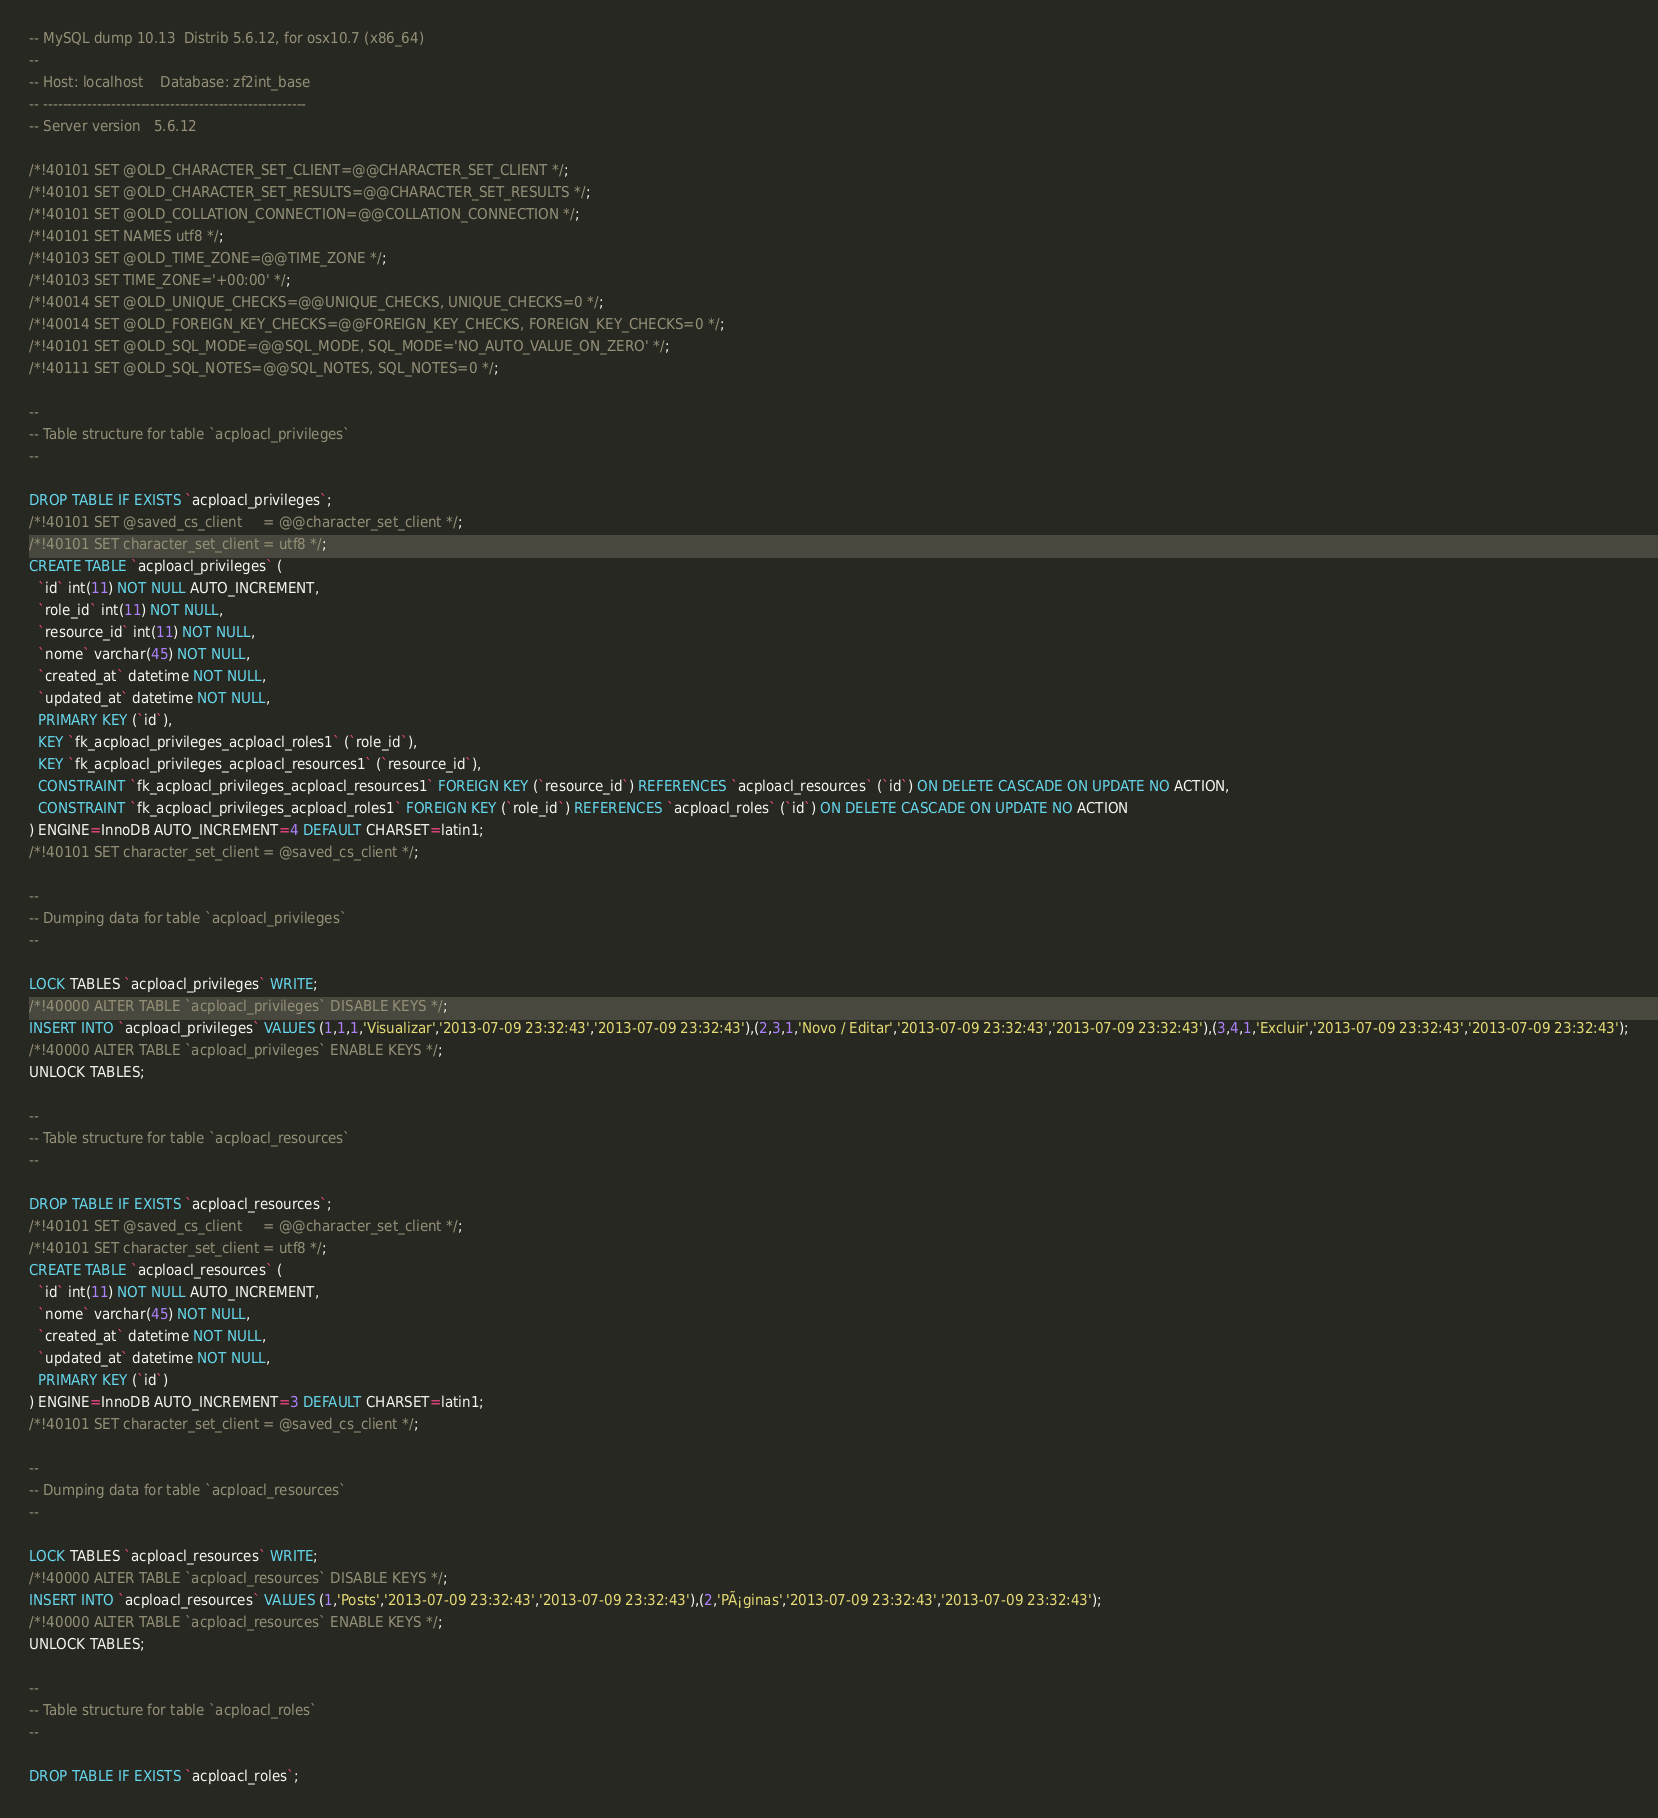Convert code to text. <code><loc_0><loc_0><loc_500><loc_500><_SQL_>-- MySQL dump 10.13  Distrib 5.6.12, for osx10.7 (x86_64)
--
-- Host: localhost    Database: zf2int_base
-- ------------------------------------------------------
-- Server version	5.6.12

/*!40101 SET @OLD_CHARACTER_SET_CLIENT=@@CHARACTER_SET_CLIENT */;
/*!40101 SET @OLD_CHARACTER_SET_RESULTS=@@CHARACTER_SET_RESULTS */;
/*!40101 SET @OLD_COLLATION_CONNECTION=@@COLLATION_CONNECTION */;
/*!40101 SET NAMES utf8 */;
/*!40103 SET @OLD_TIME_ZONE=@@TIME_ZONE */;
/*!40103 SET TIME_ZONE='+00:00' */;
/*!40014 SET @OLD_UNIQUE_CHECKS=@@UNIQUE_CHECKS, UNIQUE_CHECKS=0 */;
/*!40014 SET @OLD_FOREIGN_KEY_CHECKS=@@FOREIGN_KEY_CHECKS, FOREIGN_KEY_CHECKS=0 */;
/*!40101 SET @OLD_SQL_MODE=@@SQL_MODE, SQL_MODE='NO_AUTO_VALUE_ON_ZERO' */;
/*!40111 SET @OLD_SQL_NOTES=@@SQL_NOTES, SQL_NOTES=0 */;

--
-- Table structure for table `acploacl_privileges`
--

DROP TABLE IF EXISTS `acploacl_privileges`;
/*!40101 SET @saved_cs_client     = @@character_set_client */;
/*!40101 SET character_set_client = utf8 */;
CREATE TABLE `acploacl_privileges` (
  `id` int(11) NOT NULL AUTO_INCREMENT,
  `role_id` int(11) NOT NULL,
  `resource_id` int(11) NOT NULL,
  `nome` varchar(45) NOT NULL,
  `created_at` datetime NOT NULL,
  `updated_at` datetime NOT NULL,
  PRIMARY KEY (`id`),
  KEY `fk_acploacl_privileges_acploacl_roles1` (`role_id`),
  KEY `fk_acploacl_privileges_acploacl_resources1` (`resource_id`),
  CONSTRAINT `fk_acploacl_privileges_acploacl_resources1` FOREIGN KEY (`resource_id`) REFERENCES `acploacl_resources` (`id`) ON DELETE CASCADE ON UPDATE NO ACTION,
  CONSTRAINT `fk_acploacl_privileges_acploacl_roles1` FOREIGN KEY (`role_id`) REFERENCES `acploacl_roles` (`id`) ON DELETE CASCADE ON UPDATE NO ACTION
) ENGINE=InnoDB AUTO_INCREMENT=4 DEFAULT CHARSET=latin1;
/*!40101 SET character_set_client = @saved_cs_client */;

--
-- Dumping data for table `acploacl_privileges`
--

LOCK TABLES `acploacl_privileges` WRITE;
/*!40000 ALTER TABLE `acploacl_privileges` DISABLE KEYS */;
INSERT INTO `acploacl_privileges` VALUES (1,1,1,'Visualizar','2013-07-09 23:32:43','2013-07-09 23:32:43'),(2,3,1,'Novo / Editar','2013-07-09 23:32:43','2013-07-09 23:32:43'),(3,4,1,'Excluir','2013-07-09 23:32:43','2013-07-09 23:32:43');
/*!40000 ALTER TABLE `acploacl_privileges` ENABLE KEYS */;
UNLOCK TABLES;

--
-- Table structure for table `acploacl_resources`
--

DROP TABLE IF EXISTS `acploacl_resources`;
/*!40101 SET @saved_cs_client     = @@character_set_client */;
/*!40101 SET character_set_client = utf8 */;
CREATE TABLE `acploacl_resources` (
  `id` int(11) NOT NULL AUTO_INCREMENT,
  `nome` varchar(45) NOT NULL,
  `created_at` datetime NOT NULL,
  `updated_at` datetime NOT NULL,
  PRIMARY KEY (`id`)
) ENGINE=InnoDB AUTO_INCREMENT=3 DEFAULT CHARSET=latin1;
/*!40101 SET character_set_client = @saved_cs_client */;

--
-- Dumping data for table `acploacl_resources`
--

LOCK TABLES `acploacl_resources` WRITE;
/*!40000 ALTER TABLE `acploacl_resources` DISABLE KEYS */;
INSERT INTO `acploacl_resources` VALUES (1,'Posts','2013-07-09 23:32:43','2013-07-09 23:32:43'),(2,'PÃ¡ginas','2013-07-09 23:32:43','2013-07-09 23:32:43');
/*!40000 ALTER TABLE `acploacl_resources` ENABLE KEYS */;
UNLOCK TABLES;

--
-- Table structure for table `acploacl_roles`
--

DROP TABLE IF EXISTS `acploacl_roles`;</code> 